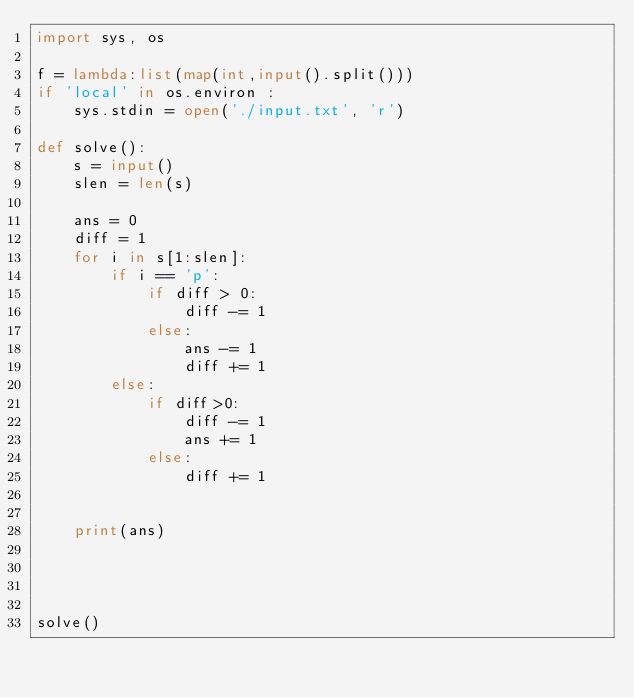<code> <loc_0><loc_0><loc_500><loc_500><_Python_>import sys, os

f = lambda:list(map(int,input().split()))
if 'local' in os.environ :
    sys.stdin = open('./input.txt', 'r')

def solve():
    s = input()
    slen = len(s)

    ans = 0
    diff = 1
    for i in s[1:slen]:
        if i == 'p':
            if diff > 0:
                diff -= 1
            else:
                ans -= 1
                diff += 1
        else:
            if diff>0:
                diff -= 1
                ans += 1
            else:
                diff += 1

    
    print(ans)
        



solve()
</code> 